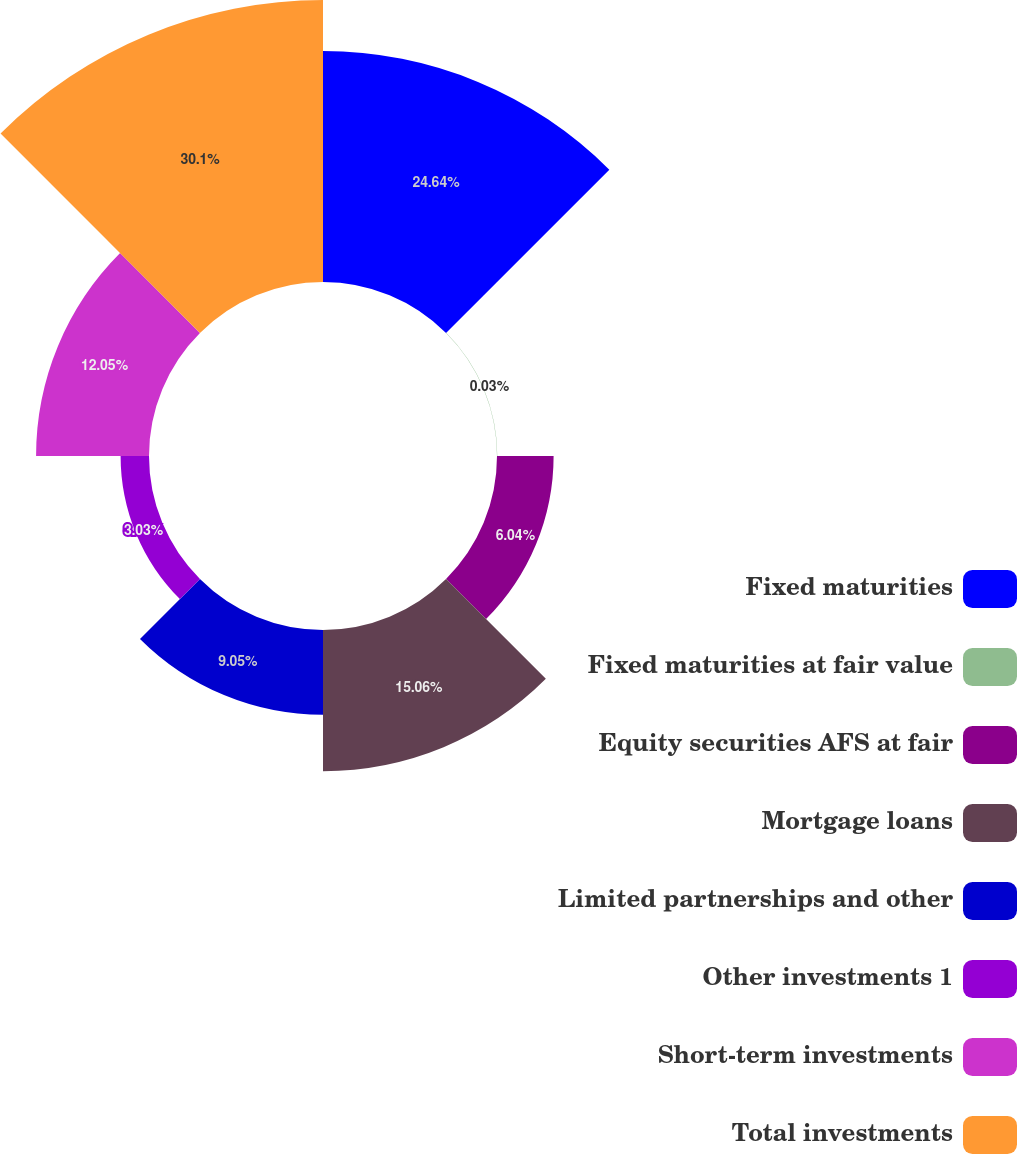Convert chart. <chart><loc_0><loc_0><loc_500><loc_500><pie_chart><fcel>Fixed maturities<fcel>Fixed maturities at fair value<fcel>Equity securities AFS at fair<fcel>Mortgage loans<fcel>Limited partnerships and other<fcel>Other investments 1<fcel>Short-term investments<fcel>Total investments<nl><fcel>24.64%<fcel>0.03%<fcel>6.04%<fcel>15.06%<fcel>9.05%<fcel>3.03%<fcel>12.05%<fcel>30.09%<nl></chart> 